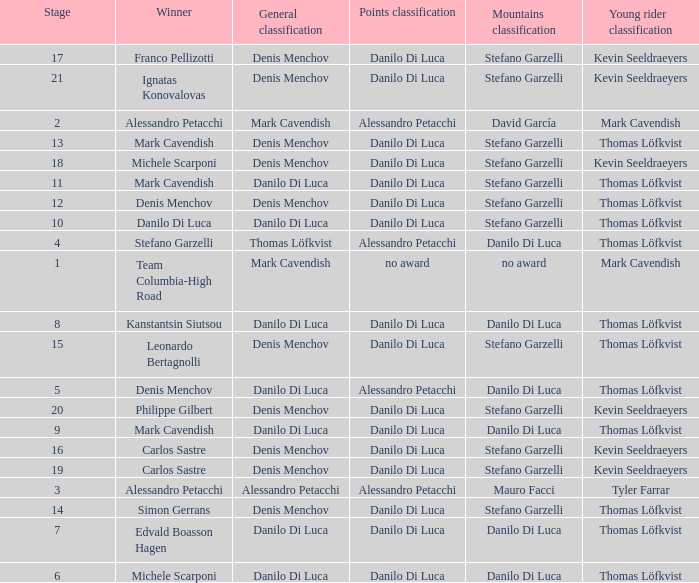When philippe gilbert is the winner who is the points classification? Danilo Di Luca. 